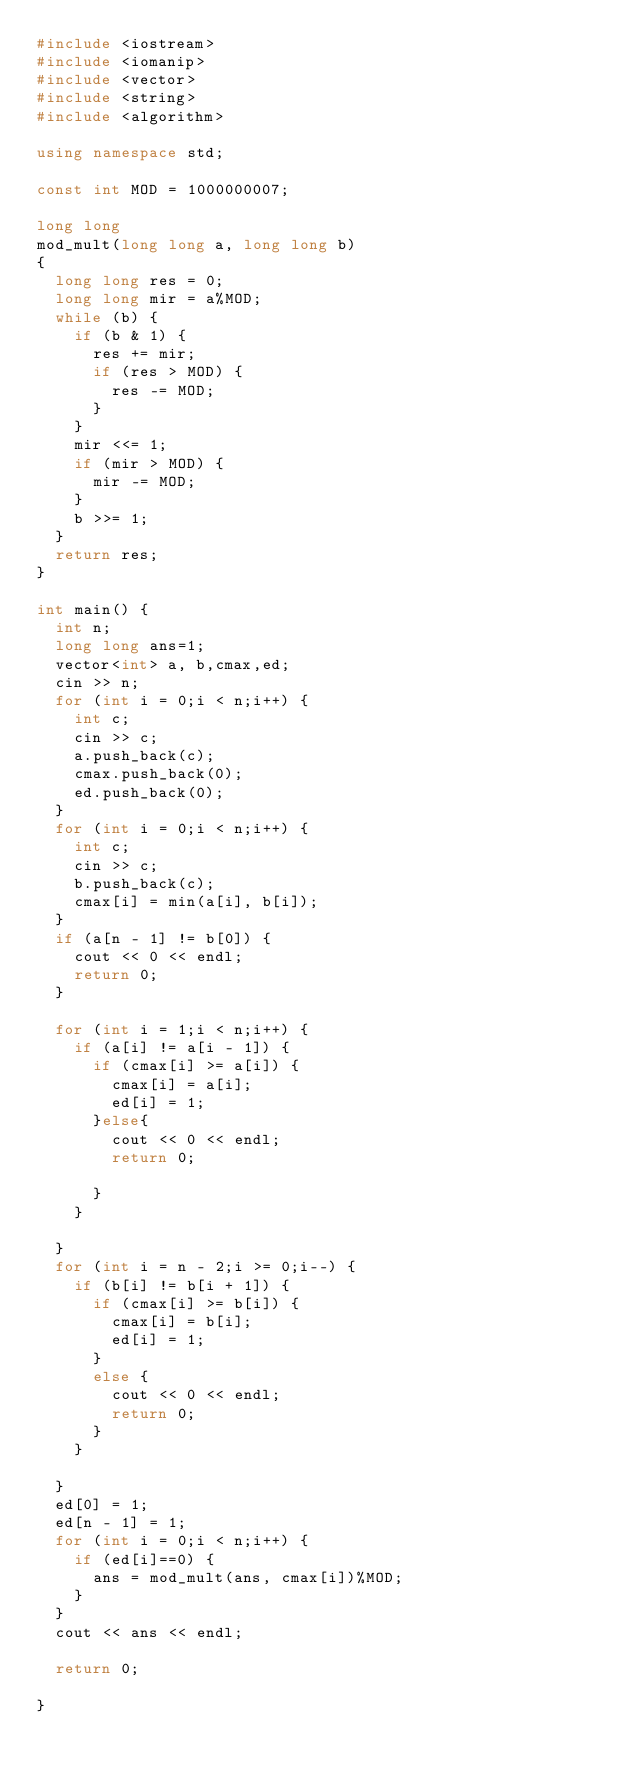<code> <loc_0><loc_0><loc_500><loc_500><_C++_>#include <iostream>
#include <iomanip>
#include <vector>
#include <string>
#include <algorithm>

using namespace std;

const int MOD = 1000000007;

long long
mod_mult(long long a, long long b)
{
	long long res = 0;
	long long mir = a%MOD;
	while (b) {
		if (b & 1) {
			res += mir;
			if (res > MOD) {
				res -= MOD;
			}
		}
		mir <<= 1;
		if (mir > MOD) {
			mir -= MOD;
		}
		b >>= 1;
	}
	return res;
}

int main() {
	int n;
	long long ans=1;
	vector<int> a, b,cmax,ed;
	cin >> n;
	for (int i = 0;i < n;i++) {
		int c;
		cin >> c;
		a.push_back(c);
		cmax.push_back(0);
		ed.push_back(0);
	}
	for (int i = 0;i < n;i++) {
		int c;
		cin >> c;
		b.push_back(c);
		cmax[i] = min(a[i], b[i]);
	}
	if (a[n - 1] != b[0]) {
		cout << 0 << endl;
		return 0;
	}
	
	for (int i = 1;i < n;i++) {
		if (a[i] != a[i - 1]) {
			if (cmax[i] >= a[i]) {
				cmax[i] = a[i];
				ed[i] = 1;
			}else{
				cout << 0 << endl;
				return 0;

			}
		}
		
	}
	for (int i = n - 2;i >= 0;i--) {
		if (b[i] != b[i + 1]) {
			if (cmax[i] >= b[i]) {
				cmax[i] = b[i];
				ed[i] = 1;
			}
			else {
				cout << 0 << endl;
				return 0;
			}
		}
		
	}
	ed[0] = 1;
	ed[n - 1] = 1;
	for (int i = 0;i < n;i++) {
		if (ed[i]==0) {
			ans = mod_mult(ans, cmax[i])%MOD;
		}
	}
	cout << ans << endl;

	return 0;
	
}</code> 